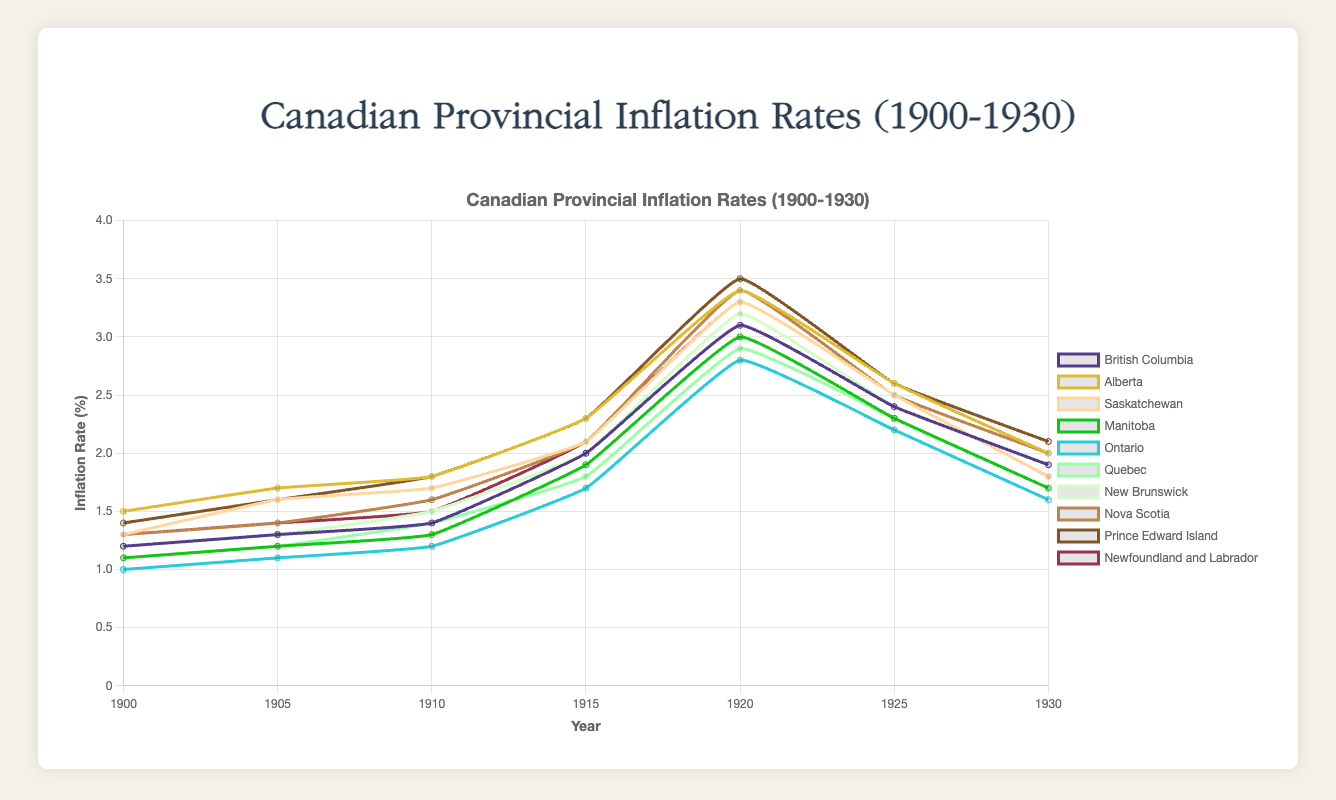What was the inflation rate trend for Ontario from 1900 to 1930? To analyze the trend, observe the line representing Ontario on the graph from 1900 to 1930. The rate starts at 1.0 in 1900, gradually increases to reach around 2.8 in 1920, then decreases back toward 1.6 by 1930.
Answer: An initial rise followed by a decline Which province had the highest inflation rate in 1920? To find this, check the highest point on the graph for the year 1920 among all provinces. Prince Edward Island has the highest rate at 3.5.
Answer: Prince Edward Island In which year did British Columbia experience the highest inflation rate, and what was the rate? Focus on the British Columbia line across the years. The highest point is in 1920, with an inflation rate of 3.1.
Answer: 1920, 3.1 Compare the inflation rate of Alberta and Saskatchewan in 1910. Which province had the higher rate and by how much? Look for the data points for Alberta and Saskatchewan in 1910. Alberta had an inflation rate of 1.8, and Saskatchewan had 1.7. The difference is 0.1.
Answer: Alberta by 0.1 What is the average inflation rate for Manitoba over the 30-year period from 1900 to 1930? Calculate the average by summing up the inflation rates for Manitoba over the years (1.1 + 1.2 + 1.3 + 1.9 + 3.0 + 2.3 + 1.7) and then divide by the number of entries (7). Sum = 12.5, Average = 12.5 / 7.
Answer: 1.79 How did the inflation rate for Nova Scotia change from 1915 to 1920? Identify the rates for Nova Scotia in 1915 (2.1) and 1920 (3.4). Calculate the difference by subtracting the 1915 rate from the 1920 rate (3.4 - 2.1).
Answer: Increased by 1.3 Which province had the least fluctuation in inflation rate over the period, and what evidence supports this? Observe all the provincial lines to determine the one with the least vertical movement. Ontario shows the least fluctuation, with rates ranging modestly compared to others.
Answer: Ontario What was the combined inflation rate of Quebec and New Brunswick in 1930? Add the inflation rates of Quebec (1.7) and New Brunswick (1.9) for 1930. The combined rate is 1.7 + 1.9.
Answer: 3.6 Which province experienced a decrease in inflation rate between 1925 and 1930 and by how much? Analyze the rates for each province in 1925 and 1930. British Columbia had 2.4 in 1925 and 1.9 in 1930. The decrease is 2.4 - 1.9.
Answer: British Columbia by 0.5 Was there a year when all provinces experienced an increase in inflation rate compared to the previous recorded year? If so, which year? Compare each province’s rate with the previous point. In 1915, all provinces recorded an increase compared to 1910.
Answer: 1915 